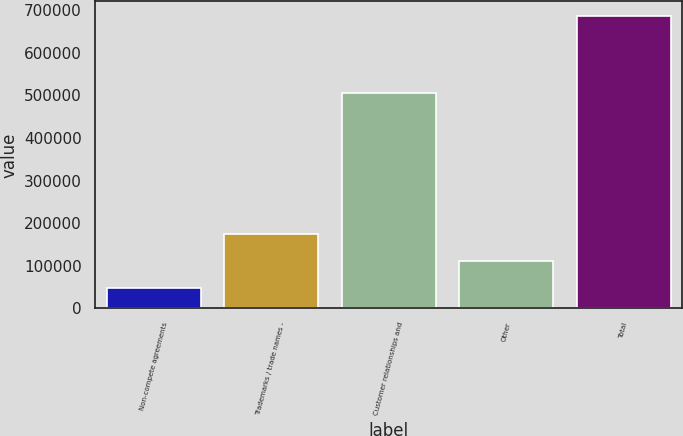<chart> <loc_0><loc_0><loc_500><loc_500><bar_chart><fcel>Non-compete agreements<fcel>Trademarks / trade names -<fcel>Customer relationships and<fcel>Other<fcel>Total<nl><fcel>47351<fcel>175034<fcel>504387<fcel>111192<fcel>685764<nl></chart> 